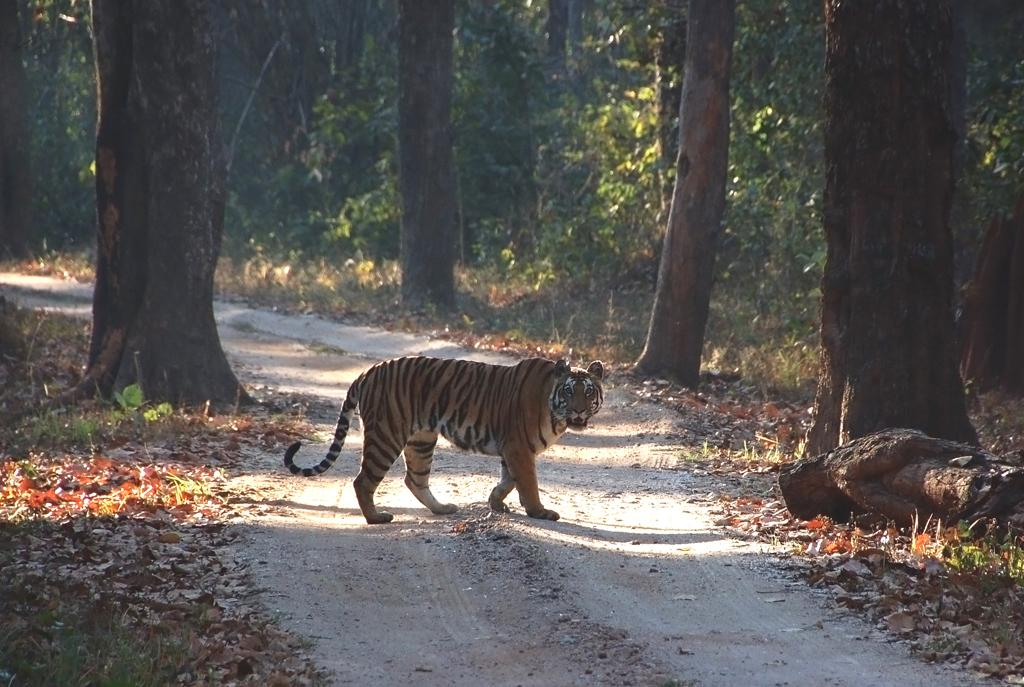Where was the image taken? The image was clicked outside. What can be seen in the middle of the image? There are trees and a tiger in the middle of the image. What type of lipstick is the tiger wearing in the image? There is no lipstick or any indication of the tiger wearing lipstick in the image. 